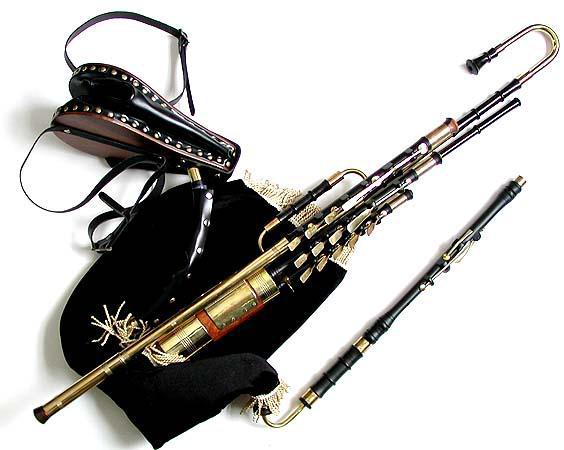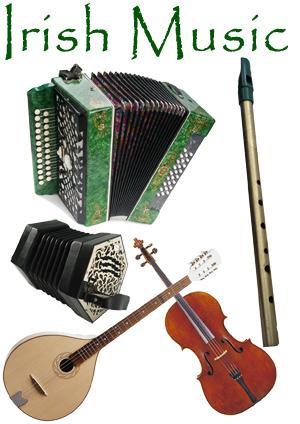The first image is the image on the left, the second image is the image on the right. For the images shown, is this caption "There are exactly two flutes." true? Answer yes or no. No. The first image is the image on the left, the second image is the image on the right. Examine the images to the left and right. Is the description "There is a total of two instruments." accurate? Answer yes or no. No. 